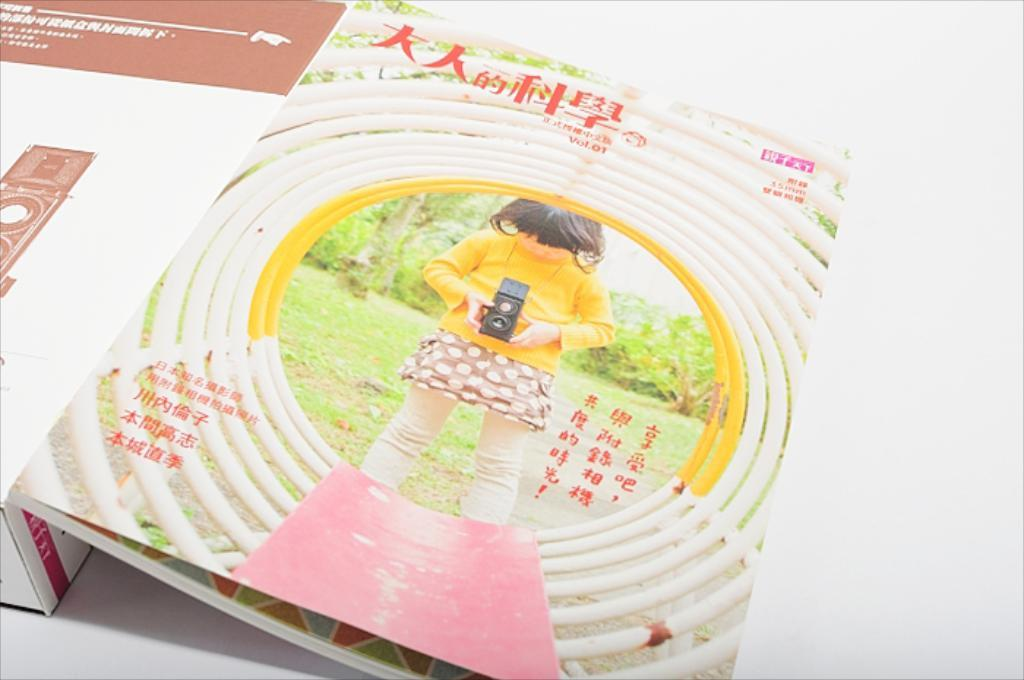What is the main object in the image? There is a book in the image. What can be seen inside the book? The book contains an image of a girl. What is the girl holding in the image within the book? The girl is holding a camera in the image. What type of suit is the girl wearing in the image? There is no suit visible in the image; the girl is holding a camera in the image within the book. What is the girl doing to the camera in the image? The girl is not performing any action on the camera in the image; she is simply holding it. 